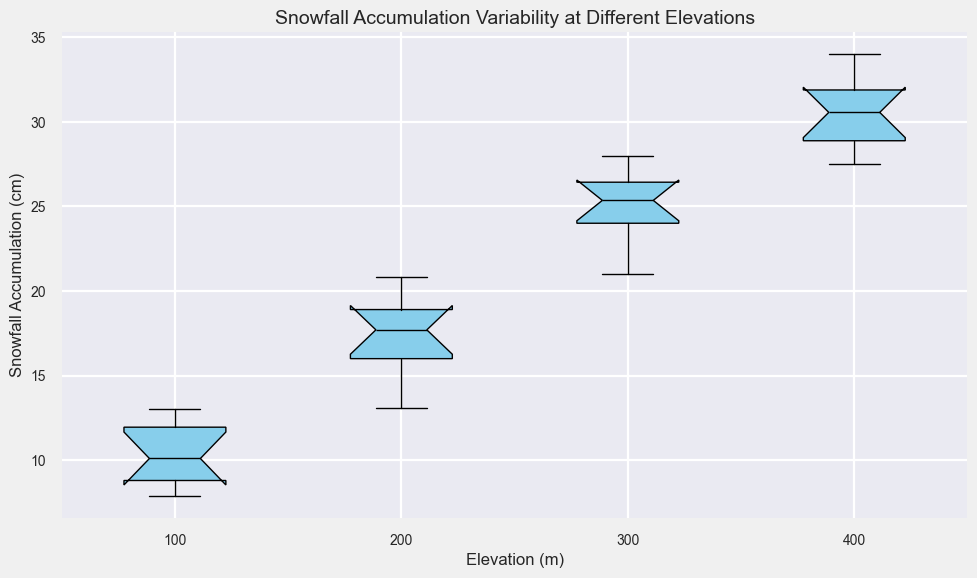Which elevation has the highest median snowfall accumulation? By examining the visual position of the median lines in the box plots, we can see that the box plot corresponding to the 400m elevation has the highest median line.
Answer: 400m How does the interquartile range (IQR) of snowfall accumulation compare between 200m and 300m elevations? The IQR is the range between the first quartile (Q1) and the third quartile (Q3). By visually comparing the box heights, the IQR for the 300m elevation is larger than that for the 200m elevation.
Answer: 300m > 200m What is the approximate range of snowfall accumulation at 100m elevation? The range is from the minimum to the maximum values, which corresponds to the lowest and highest whiskers in the box plot. For 100m elevation, it ranges from about 7.9 to 13.0 cm.
Answer: 7.9 - 13.0 cm At which elevation is the snowfall accumulation more consistent, 300m or 400m? Consistency can be inferred by the spread of the data. A narrower box plot (smaller IQR) indicates more consistent data. The IQR for 300m is smaller compared to 400m, so 300m has more consistent snowfall accumulation.
Answer: 300m Are there any outliers in the snowfall accumulation data at any elevation? Outliers are identified by points that lie outside the whiskers of the box plots. Based on the figure, there are no outliers visible in any of the elevation box plots.
Answer: No Which two elevations have the closest median snowfall accumulation? By comparing the median lines in each box plot, the elevations 300m and 400m have the closest median snowfall accumulations.
Answer: 300m and 400m Is the snowfall accumulation at higher elevations generally higher than at lower elevations? By visually inspecting the box plots from left to right (increasing elevation), it is clear that the median snowfall accumulation increases with elevation.
Answer: Yes What is the median snowfall accumulation at 200m elevation? By locating the median line (the line inside the box) on the box plot for 200m elevation, it is approximately at 18 cm.
Answer: 18 cm Between which two elevations is the difference in median snowfall accumulation the greatest? By comparing the distances between the median lines of each elevation, the greatest difference in median snowfall accumulation appears between 100m and 200m elevations.
Answer: 100m and 200m 